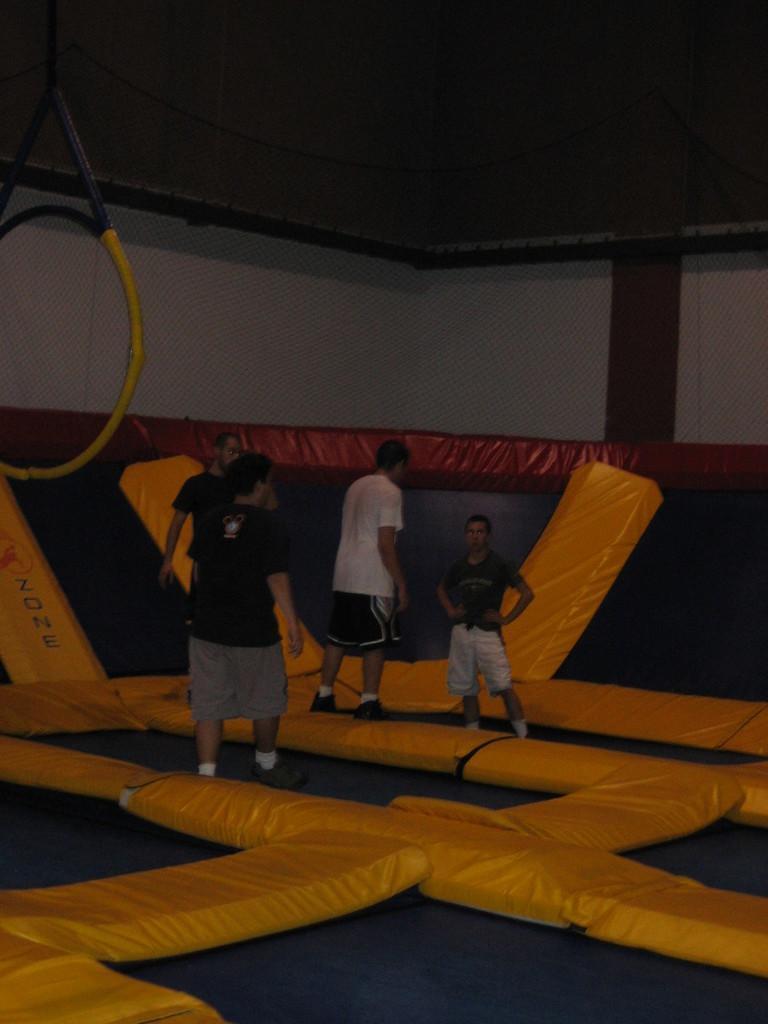How would you summarize this image in a sentence or two? In this picture I can see group of people are standing on an object. In the background I can see a wall and some yellow color objects. 